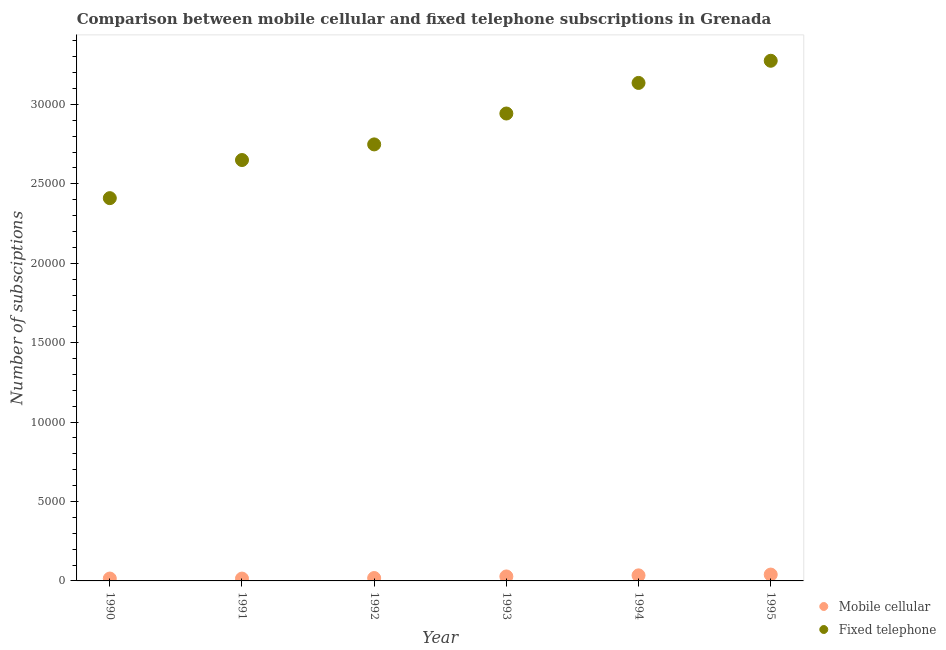How many different coloured dotlines are there?
Your answer should be very brief. 2. Is the number of dotlines equal to the number of legend labels?
Your response must be concise. Yes. What is the number of mobile cellular subscriptions in 1994?
Make the answer very short. 350. Across all years, what is the maximum number of fixed telephone subscriptions?
Your answer should be very brief. 3.28e+04. Across all years, what is the minimum number of fixed telephone subscriptions?
Ensure brevity in your answer.  2.41e+04. In which year was the number of fixed telephone subscriptions minimum?
Offer a very short reply. 1990. What is the total number of fixed telephone subscriptions in the graph?
Your answer should be very brief. 1.72e+05. What is the difference between the number of fixed telephone subscriptions in 1992 and that in 1995?
Make the answer very short. -5266. What is the difference between the number of fixed telephone subscriptions in 1992 and the number of mobile cellular subscriptions in 1991?
Offer a very short reply. 2.73e+04. What is the average number of mobile cellular subscriptions per year?
Your response must be concise. 251.67. In the year 1991, what is the difference between the number of fixed telephone subscriptions and number of mobile cellular subscriptions?
Keep it short and to the point. 2.64e+04. In how many years, is the number of fixed telephone subscriptions greater than 26000?
Your answer should be compact. 5. What is the ratio of the number of fixed telephone subscriptions in 1991 to that in 1994?
Offer a very short reply. 0.85. Is the number of fixed telephone subscriptions in 1990 less than that in 1991?
Provide a short and direct response. Yes. What is the difference between the highest and the lowest number of mobile cellular subscriptions?
Your response must be concise. 253. In how many years, is the number of fixed telephone subscriptions greater than the average number of fixed telephone subscriptions taken over all years?
Give a very brief answer. 3. Is the sum of the number of mobile cellular subscriptions in 1991 and 1993 greater than the maximum number of fixed telephone subscriptions across all years?
Keep it short and to the point. No. Does the number of fixed telephone subscriptions monotonically increase over the years?
Offer a terse response. Yes. Is the number of mobile cellular subscriptions strictly greater than the number of fixed telephone subscriptions over the years?
Offer a terse response. No. Is the number of fixed telephone subscriptions strictly less than the number of mobile cellular subscriptions over the years?
Provide a succinct answer. No. Does the graph contain any zero values?
Provide a succinct answer. No. Does the graph contain grids?
Your answer should be compact. No. What is the title of the graph?
Provide a short and direct response. Comparison between mobile cellular and fixed telephone subscriptions in Grenada. What is the label or title of the Y-axis?
Provide a succinct answer. Number of subsciptions. What is the Number of subsciptions of Mobile cellular in 1990?
Provide a short and direct response. 150. What is the Number of subsciptions of Fixed telephone in 1990?
Offer a very short reply. 2.41e+04. What is the Number of subsciptions in Mobile cellular in 1991?
Make the answer very short. 147. What is the Number of subsciptions in Fixed telephone in 1991?
Offer a very short reply. 2.65e+04. What is the Number of subsciptions in Mobile cellular in 1992?
Your answer should be very brief. 181. What is the Number of subsciptions of Fixed telephone in 1992?
Your response must be concise. 2.75e+04. What is the Number of subsciptions in Mobile cellular in 1993?
Your answer should be compact. 282. What is the Number of subsciptions in Fixed telephone in 1993?
Give a very brief answer. 2.94e+04. What is the Number of subsciptions of Mobile cellular in 1994?
Offer a very short reply. 350. What is the Number of subsciptions in Fixed telephone in 1994?
Make the answer very short. 3.14e+04. What is the Number of subsciptions in Fixed telephone in 1995?
Provide a short and direct response. 3.28e+04. Across all years, what is the maximum Number of subsciptions in Fixed telephone?
Offer a very short reply. 3.28e+04. Across all years, what is the minimum Number of subsciptions of Mobile cellular?
Your answer should be compact. 147. Across all years, what is the minimum Number of subsciptions in Fixed telephone?
Give a very brief answer. 2.41e+04. What is the total Number of subsciptions in Mobile cellular in the graph?
Offer a terse response. 1510. What is the total Number of subsciptions in Fixed telephone in the graph?
Your answer should be very brief. 1.72e+05. What is the difference between the Number of subsciptions of Mobile cellular in 1990 and that in 1991?
Your answer should be very brief. 3. What is the difference between the Number of subsciptions in Fixed telephone in 1990 and that in 1991?
Your answer should be very brief. -2400. What is the difference between the Number of subsciptions of Mobile cellular in 1990 and that in 1992?
Ensure brevity in your answer.  -31. What is the difference between the Number of subsciptions of Fixed telephone in 1990 and that in 1992?
Offer a terse response. -3384. What is the difference between the Number of subsciptions in Mobile cellular in 1990 and that in 1993?
Offer a terse response. -132. What is the difference between the Number of subsciptions of Fixed telephone in 1990 and that in 1993?
Ensure brevity in your answer.  -5329. What is the difference between the Number of subsciptions of Mobile cellular in 1990 and that in 1994?
Your response must be concise. -200. What is the difference between the Number of subsciptions of Fixed telephone in 1990 and that in 1994?
Your answer should be compact. -7255. What is the difference between the Number of subsciptions of Mobile cellular in 1990 and that in 1995?
Your answer should be compact. -250. What is the difference between the Number of subsciptions of Fixed telephone in 1990 and that in 1995?
Your response must be concise. -8650. What is the difference between the Number of subsciptions of Mobile cellular in 1991 and that in 1992?
Give a very brief answer. -34. What is the difference between the Number of subsciptions in Fixed telephone in 1991 and that in 1992?
Ensure brevity in your answer.  -984. What is the difference between the Number of subsciptions in Mobile cellular in 1991 and that in 1993?
Ensure brevity in your answer.  -135. What is the difference between the Number of subsciptions in Fixed telephone in 1991 and that in 1993?
Make the answer very short. -2929. What is the difference between the Number of subsciptions of Mobile cellular in 1991 and that in 1994?
Offer a terse response. -203. What is the difference between the Number of subsciptions of Fixed telephone in 1991 and that in 1994?
Provide a short and direct response. -4855. What is the difference between the Number of subsciptions in Mobile cellular in 1991 and that in 1995?
Give a very brief answer. -253. What is the difference between the Number of subsciptions of Fixed telephone in 1991 and that in 1995?
Your answer should be very brief. -6250. What is the difference between the Number of subsciptions in Mobile cellular in 1992 and that in 1993?
Give a very brief answer. -101. What is the difference between the Number of subsciptions of Fixed telephone in 1992 and that in 1993?
Keep it short and to the point. -1945. What is the difference between the Number of subsciptions in Mobile cellular in 1992 and that in 1994?
Your answer should be compact. -169. What is the difference between the Number of subsciptions in Fixed telephone in 1992 and that in 1994?
Provide a succinct answer. -3871. What is the difference between the Number of subsciptions of Mobile cellular in 1992 and that in 1995?
Your answer should be very brief. -219. What is the difference between the Number of subsciptions in Fixed telephone in 1992 and that in 1995?
Your answer should be very brief. -5266. What is the difference between the Number of subsciptions of Mobile cellular in 1993 and that in 1994?
Provide a short and direct response. -68. What is the difference between the Number of subsciptions in Fixed telephone in 1993 and that in 1994?
Offer a very short reply. -1926. What is the difference between the Number of subsciptions in Mobile cellular in 1993 and that in 1995?
Provide a short and direct response. -118. What is the difference between the Number of subsciptions in Fixed telephone in 1993 and that in 1995?
Provide a succinct answer. -3321. What is the difference between the Number of subsciptions in Mobile cellular in 1994 and that in 1995?
Make the answer very short. -50. What is the difference between the Number of subsciptions of Fixed telephone in 1994 and that in 1995?
Provide a short and direct response. -1395. What is the difference between the Number of subsciptions of Mobile cellular in 1990 and the Number of subsciptions of Fixed telephone in 1991?
Your response must be concise. -2.64e+04. What is the difference between the Number of subsciptions in Mobile cellular in 1990 and the Number of subsciptions in Fixed telephone in 1992?
Make the answer very short. -2.73e+04. What is the difference between the Number of subsciptions in Mobile cellular in 1990 and the Number of subsciptions in Fixed telephone in 1993?
Offer a terse response. -2.93e+04. What is the difference between the Number of subsciptions of Mobile cellular in 1990 and the Number of subsciptions of Fixed telephone in 1994?
Ensure brevity in your answer.  -3.12e+04. What is the difference between the Number of subsciptions of Mobile cellular in 1990 and the Number of subsciptions of Fixed telephone in 1995?
Ensure brevity in your answer.  -3.26e+04. What is the difference between the Number of subsciptions of Mobile cellular in 1991 and the Number of subsciptions of Fixed telephone in 1992?
Give a very brief answer. -2.73e+04. What is the difference between the Number of subsciptions of Mobile cellular in 1991 and the Number of subsciptions of Fixed telephone in 1993?
Offer a very short reply. -2.93e+04. What is the difference between the Number of subsciptions in Mobile cellular in 1991 and the Number of subsciptions in Fixed telephone in 1994?
Your answer should be very brief. -3.12e+04. What is the difference between the Number of subsciptions in Mobile cellular in 1991 and the Number of subsciptions in Fixed telephone in 1995?
Offer a terse response. -3.26e+04. What is the difference between the Number of subsciptions of Mobile cellular in 1992 and the Number of subsciptions of Fixed telephone in 1993?
Your answer should be very brief. -2.92e+04. What is the difference between the Number of subsciptions in Mobile cellular in 1992 and the Number of subsciptions in Fixed telephone in 1994?
Your answer should be compact. -3.12e+04. What is the difference between the Number of subsciptions of Mobile cellular in 1992 and the Number of subsciptions of Fixed telephone in 1995?
Your response must be concise. -3.26e+04. What is the difference between the Number of subsciptions in Mobile cellular in 1993 and the Number of subsciptions in Fixed telephone in 1994?
Make the answer very short. -3.11e+04. What is the difference between the Number of subsciptions in Mobile cellular in 1993 and the Number of subsciptions in Fixed telephone in 1995?
Offer a terse response. -3.25e+04. What is the difference between the Number of subsciptions in Mobile cellular in 1994 and the Number of subsciptions in Fixed telephone in 1995?
Provide a succinct answer. -3.24e+04. What is the average Number of subsciptions in Mobile cellular per year?
Keep it short and to the point. 251.67. What is the average Number of subsciptions in Fixed telephone per year?
Keep it short and to the point. 2.86e+04. In the year 1990, what is the difference between the Number of subsciptions in Mobile cellular and Number of subsciptions in Fixed telephone?
Provide a succinct answer. -2.40e+04. In the year 1991, what is the difference between the Number of subsciptions of Mobile cellular and Number of subsciptions of Fixed telephone?
Offer a very short reply. -2.64e+04. In the year 1992, what is the difference between the Number of subsciptions in Mobile cellular and Number of subsciptions in Fixed telephone?
Provide a short and direct response. -2.73e+04. In the year 1993, what is the difference between the Number of subsciptions in Mobile cellular and Number of subsciptions in Fixed telephone?
Provide a short and direct response. -2.91e+04. In the year 1994, what is the difference between the Number of subsciptions of Mobile cellular and Number of subsciptions of Fixed telephone?
Give a very brief answer. -3.10e+04. In the year 1995, what is the difference between the Number of subsciptions in Mobile cellular and Number of subsciptions in Fixed telephone?
Keep it short and to the point. -3.24e+04. What is the ratio of the Number of subsciptions of Mobile cellular in 1990 to that in 1991?
Provide a short and direct response. 1.02. What is the ratio of the Number of subsciptions in Fixed telephone in 1990 to that in 1991?
Give a very brief answer. 0.91. What is the ratio of the Number of subsciptions of Mobile cellular in 1990 to that in 1992?
Your response must be concise. 0.83. What is the ratio of the Number of subsciptions of Fixed telephone in 1990 to that in 1992?
Your answer should be compact. 0.88. What is the ratio of the Number of subsciptions in Mobile cellular in 1990 to that in 1993?
Provide a succinct answer. 0.53. What is the ratio of the Number of subsciptions of Fixed telephone in 1990 to that in 1993?
Provide a succinct answer. 0.82. What is the ratio of the Number of subsciptions of Mobile cellular in 1990 to that in 1994?
Give a very brief answer. 0.43. What is the ratio of the Number of subsciptions of Fixed telephone in 1990 to that in 1994?
Your answer should be very brief. 0.77. What is the ratio of the Number of subsciptions in Mobile cellular in 1990 to that in 1995?
Your answer should be very brief. 0.38. What is the ratio of the Number of subsciptions in Fixed telephone in 1990 to that in 1995?
Offer a terse response. 0.74. What is the ratio of the Number of subsciptions in Mobile cellular in 1991 to that in 1992?
Offer a very short reply. 0.81. What is the ratio of the Number of subsciptions of Fixed telephone in 1991 to that in 1992?
Provide a short and direct response. 0.96. What is the ratio of the Number of subsciptions of Mobile cellular in 1991 to that in 1993?
Offer a terse response. 0.52. What is the ratio of the Number of subsciptions in Fixed telephone in 1991 to that in 1993?
Provide a succinct answer. 0.9. What is the ratio of the Number of subsciptions of Mobile cellular in 1991 to that in 1994?
Offer a very short reply. 0.42. What is the ratio of the Number of subsciptions in Fixed telephone in 1991 to that in 1994?
Your answer should be very brief. 0.85. What is the ratio of the Number of subsciptions of Mobile cellular in 1991 to that in 1995?
Provide a short and direct response. 0.37. What is the ratio of the Number of subsciptions in Fixed telephone in 1991 to that in 1995?
Keep it short and to the point. 0.81. What is the ratio of the Number of subsciptions in Mobile cellular in 1992 to that in 1993?
Ensure brevity in your answer.  0.64. What is the ratio of the Number of subsciptions of Fixed telephone in 1992 to that in 1993?
Your answer should be compact. 0.93. What is the ratio of the Number of subsciptions in Mobile cellular in 1992 to that in 1994?
Make the answer very short. 0.52. What is the ratio of the Number of subsciptions in Fixed telephone in 1992 to that in 1994?
Provide a short and direct response. 0.88. What is the ratio of the Number of subsciptions in Mobile cellular in 1992 to that in 1995?
Provide a short and direct response. 0.45. What is the ratio of the Number of subsciptions of Fixed telephone in 1992 to that in 1995?
Offer a very short reply. 0.84. What is the ratio of the Number of subsciptions of Mobile cellular in 1993 to that in 1994?
Your response must be concise. 0.81. What is the ratio of the Number of subsciptions of Fixed telephone in 1993 to that in 1994?
Provide a succinct answer. 0.94. What is the ratio of the Number of subsciptions in Mobile cellular in 1993 to that in 1995?
Provide a short and direct response. 0.7. What is the ratio of the Number of subsciptions of Fixed telephone in 1993 to that in 1995?
Provide a succinct answer. 0.9. What is the ratio of the Number of subsciptions of Mobile cellular in 1994 to that in 1995?
Give a very brief answer. 0.88. What is the ratio of the Number of subsciptions of Fixed telephone in 1994 to that in 1995?
Provide a succinct answer. 0.96. What is the difference between the highest and the second highest Number of subsciptions in Mobile cellular?
Ensure brevity in your answer.  50. What is the difference between the highest and the second highest Number of subsciptions in Fixed telephone?
Your answer should be compact. 1395. What is the difference between the highest and the lowest Number of subsciptions of Mobile cellular?
Offer a very short reply. 253. What is the difference between the highest and the lowest Number of subsciptions of Fixed telephone?
Keep it short and to the point. 8650. 